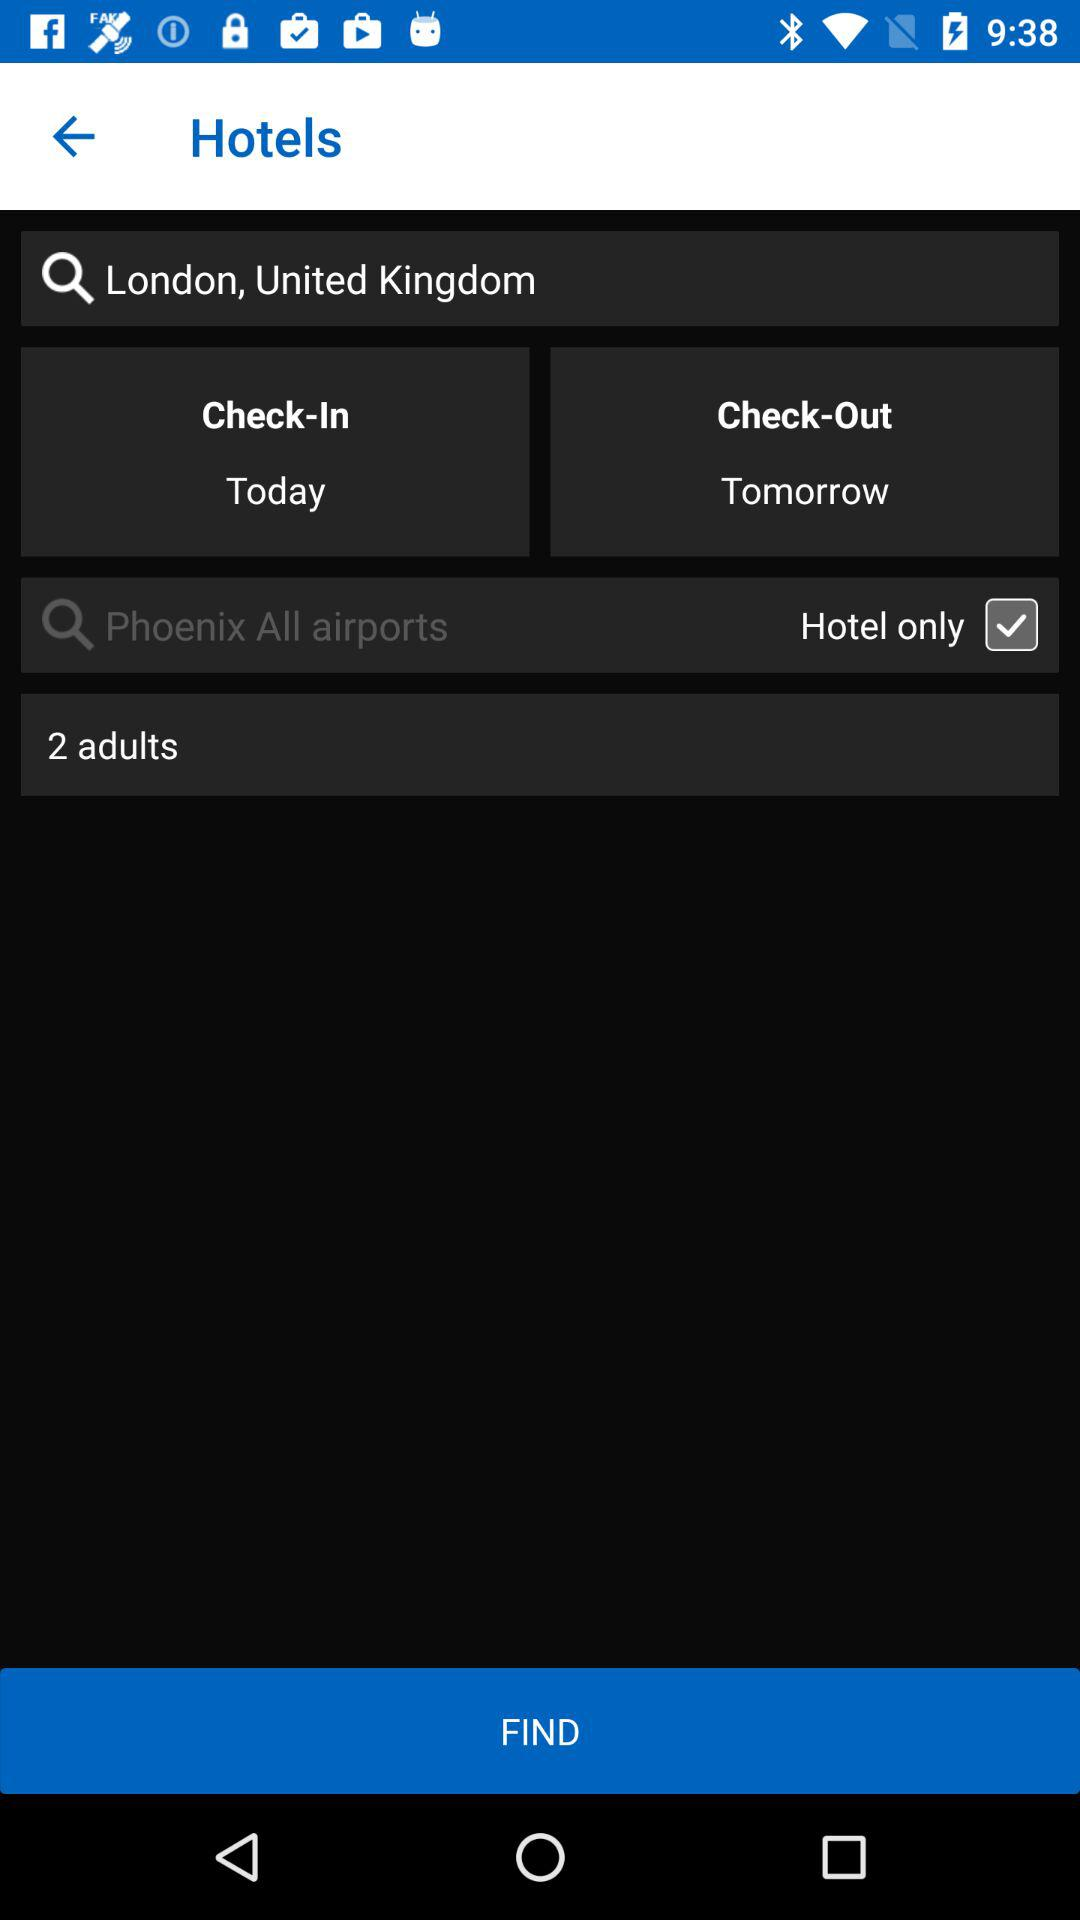What is the status of "Hotel only"? The status of "Hotel only" is on. 